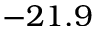<formula> <loc_0><loc_0><loc_500><loc_500>- 2 1 . 9</formula> 